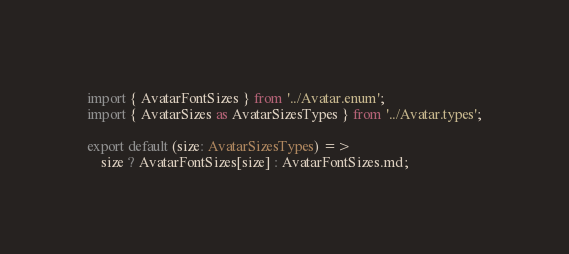Convert code to text. <code><loc_0><loc_0><loc_500><loc_500><_TypeScript_>import { AvatarFontSizes } from '../Avatar.enum';
import { AvatarSizes as AvatarSizesTypes } from '../Avatar.types';

export default (size: AvatarSizesTypes) =>
	size ? AvatarFontSizes[size] : AvatarFontSizes.md;
</code> 